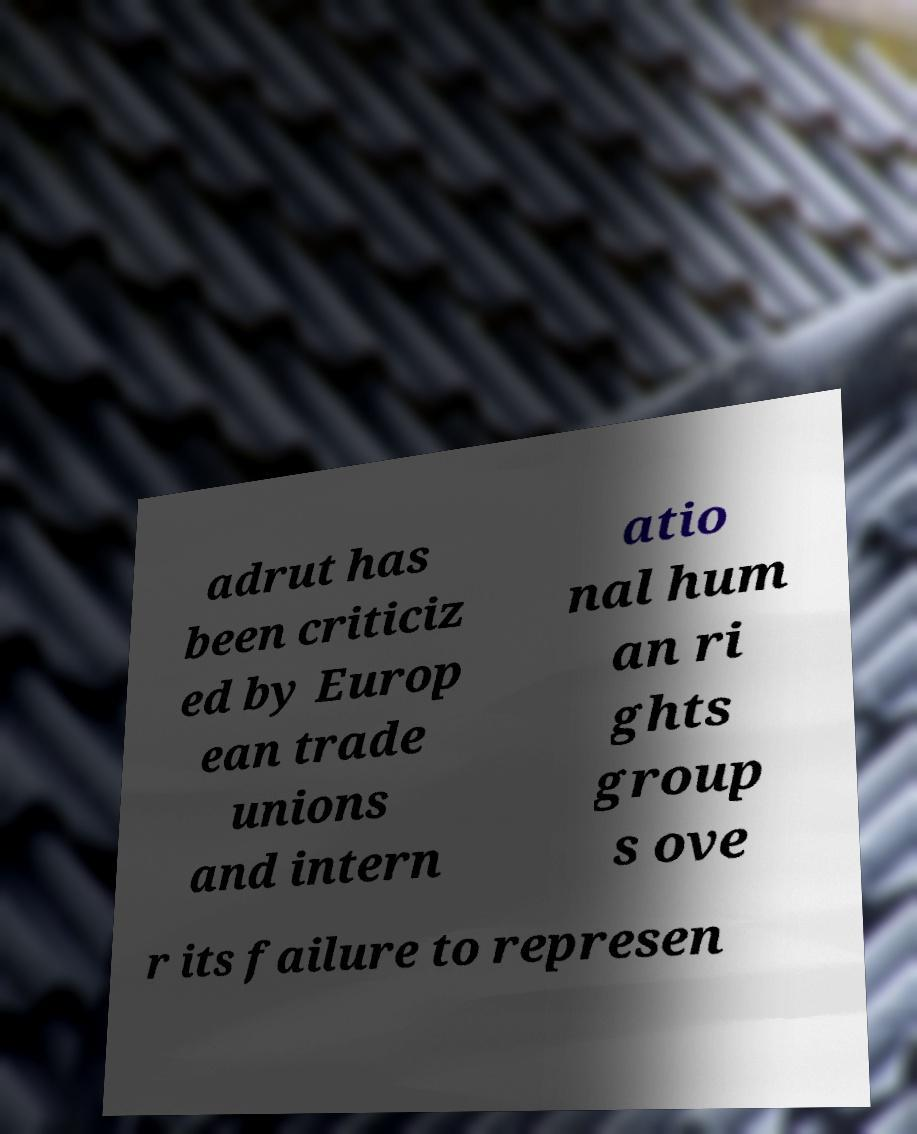Please read and relay the text visible in this image. What does it say? adrut has been criticiz ed by Europ ean trade unions and intern atio nal hum an ri ghts group s ove r its failure to represen 